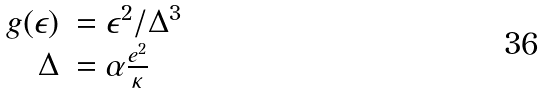Convert formula to latex. <formula><loc_0><loc_0><loc_500><loc_500>\begin{array} { r l } g ( \epsilon ) & = \epsilon ^ { 2 } / \Delta ^ { 3 } \\ \Delta & = \alpha \frac { e ^ { 2 } } { \kappa } \end{array}</formula> 